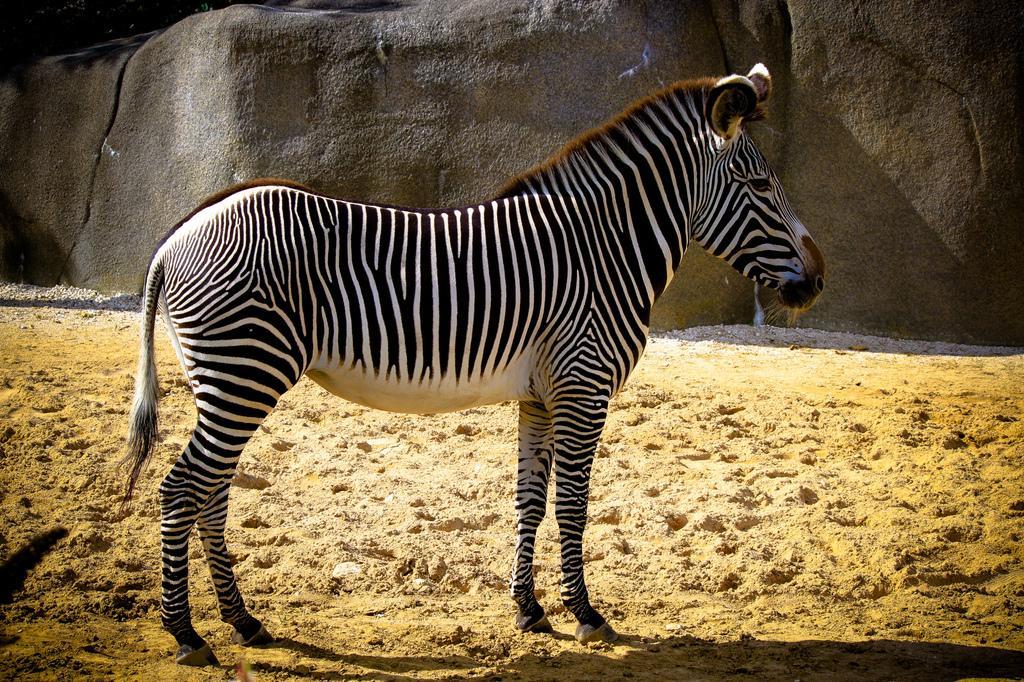Please provide a concise description of this image. In this image I can see an animal which is in black and white color. It is on the ground. In the background I can see the rock. 